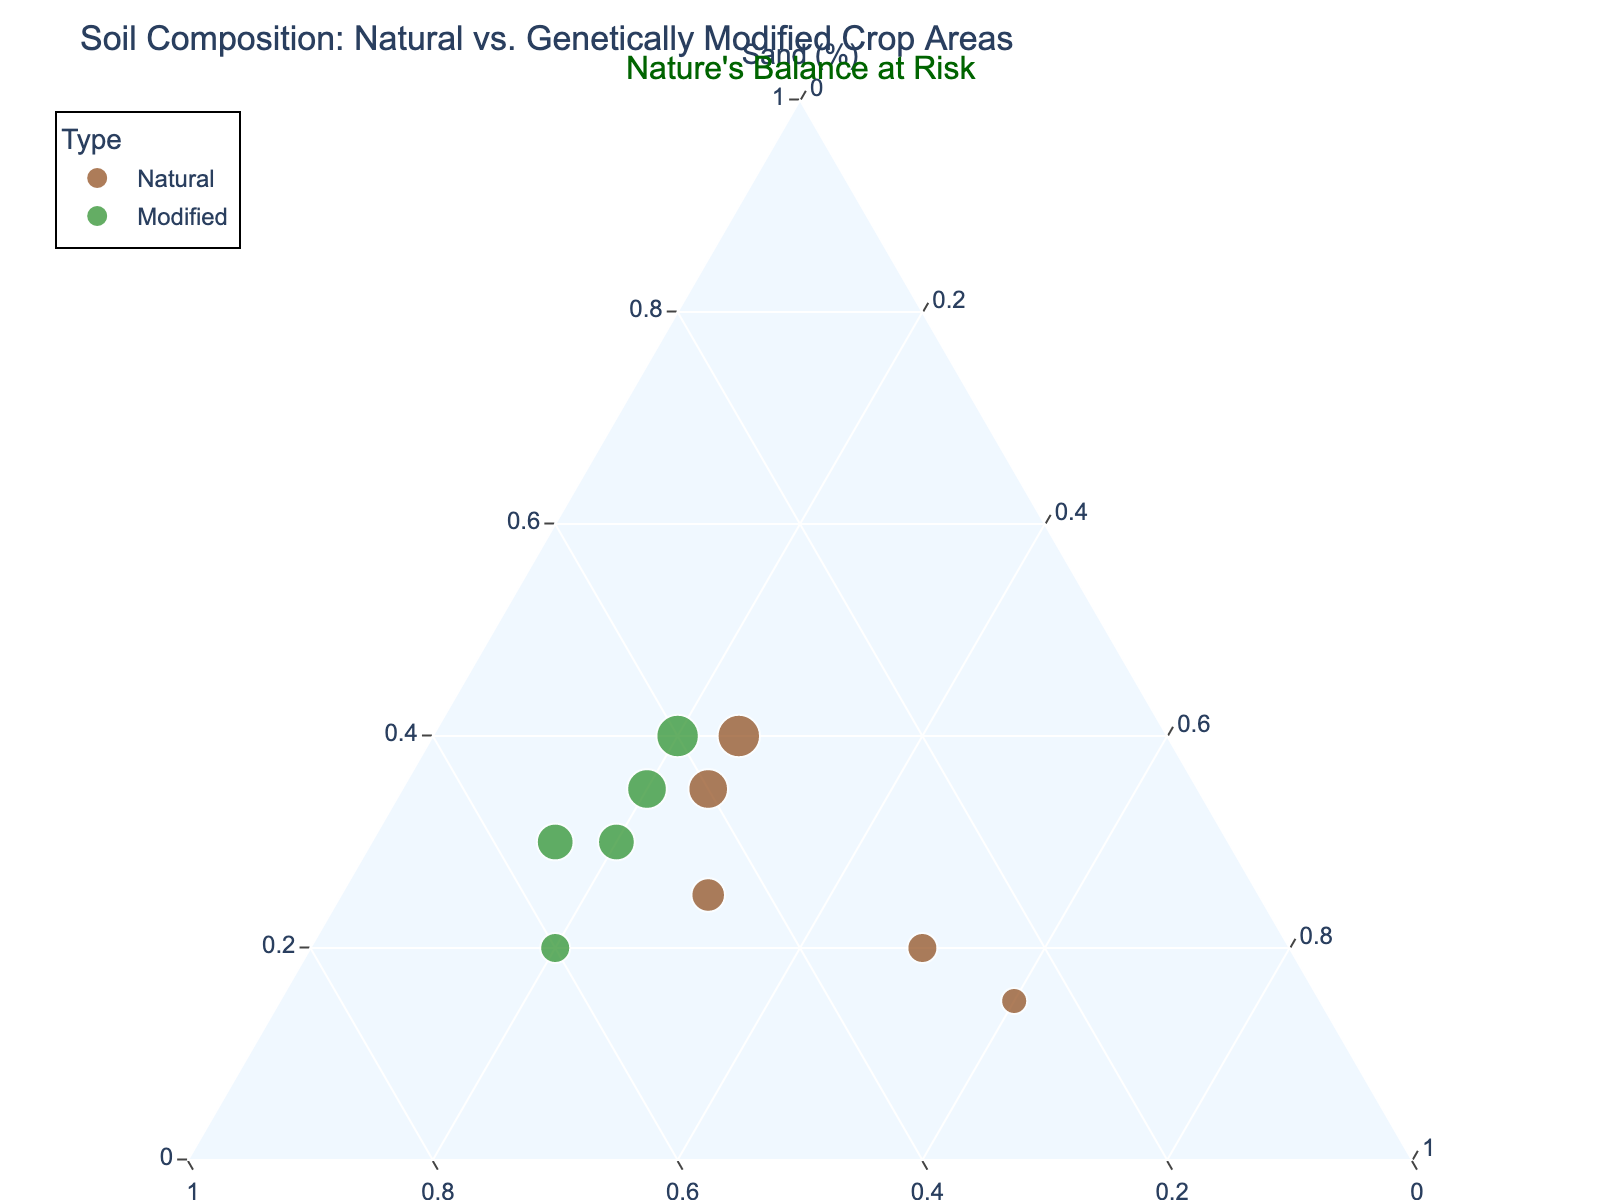What does the title of the figure indicate? The title "Soil Composition: Natural vs. Genetically Modified Crop Areas" indicates the figure is comparing the soil composition between natural and genetically modified crop areas.
Answer: Comparison of soil composition What colors represent natural and genetically modified areas? The custom color scale uses brown for natural areas and green for genetically modified areas. This can be seen in the color legend of the plot.
Answer: Brown and green How many samples are represented in the plot, and how are they categorized? The plot includes 10 samples, categorized into "Natural" and "Modified" types. There are 5 samples in each category, as displayed by their respective colors.
Answer: 10 samples: 5 natural, 5 modified What is the percentage composition of clay in the Coastal Wetland sample compared to the GM Canola Field? The Coastal Wetland sample has 60% clay content, while the GM Canola Field has 15% clay content. This difference can be observed by locating the positions of these points on the ternary plot.
Answer: 60% vs. 15% Which type of crop area demonstrates greater variability in soil composition, natural or modified? Natural crop areas exhibit greater variability in soil composition, as their points are more spread out across the ternary plot. Genetically modified crop areas are clustered closer together, indicating less variability.
Answer: Natural areas Which sample has the highest Silt content and what type of land does it belong to? The GM Rice Paddy sample has the highest silt content at 60%. This can be observed from the plot where it's positioned farthest along the Silt axis.
Answer: GM Rice Paddy Compare the sand content in GM Cotton Field and Prairie Grassland, which one has more sand? Both GM Cotton Field and Prairie Grassland have 40% sand content. This is evident from their positions on the plot along the Sand axis.
Answer: Equal, 40% each What is the average sand content in natural crop areas? The sand contents in natural areas are: 20 (Amazonian Rainforest), 25 (Organic Farm Soil), 35 (Prairie Grassland), 40 (Alpine Meadow), and 15 (Coastal Wetland). The average is (20+25+35+40+15)/5 = 27%.
Answer: 27% How does the clay content of GM crop areas compare to natural areas? GM crop areas tend to have lower clay content compared to natural areas. This is visible as the GM points are closer to the Sand and Silt corners while natural points spread towards the Clay corner.
Answer: Lower in GM areas In which sample did nature’s balance appear to be at most risk according to the plot? The GM Rice Paddy demonstrates extreme silt content and lower diversity in soil composition, potentially indicating a risk to nature’s balance. This insight is supported by its farthest position along the Silt axis.
Answer: GM Rice Paddy 